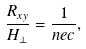Convert formula to latex. <formula><loc_0><loc_0><loc_500><loc_500>\frac { R _ { x y } } { H _ { \perp } } = \frac { 1 } { n e c } ,</formula> 